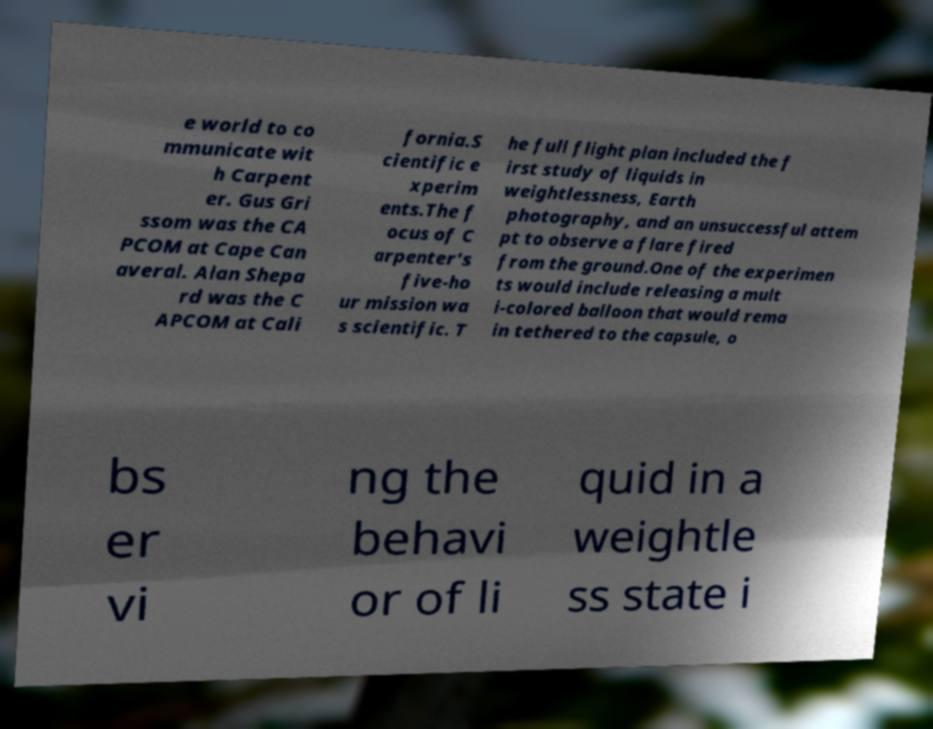I need the written content from this picture converted into text. Can you do that? e world to co mmunicate wit h Carpent er. Gus Gri ssom was the CA PCOM at Cape Can averal. Alan Shepa rd was the C APCOM at Cali fornia.S cientific e xperim ents.The f ocus of C arpenter's five-ho ur mission wa s scientific. T he full flight plan included the f irst study of liquids in weightlessness, Earth photography, and an unsuccessful attem pt to observe a flare fired from the ground.One of the experimen ts would include releasing a mult i-colored balloon that would rema in tethered to the capsule, o bs er vi ng the behavi or of li quid in a weightle ss state i 